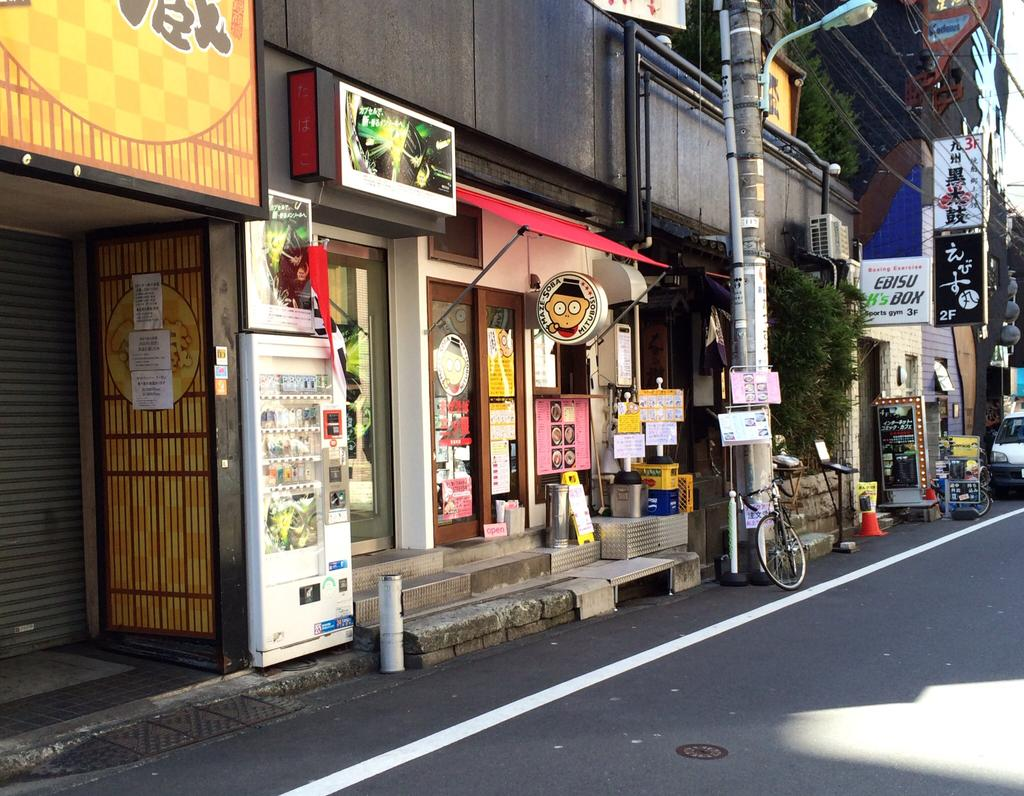What type of vehicle can be seen in the image? There is a car in the image. What other mode of transportation is visible in the image? There is a bicycle in the image. What objects are present in the image that might be used for construction or signage? There are boards and poles in the image. What source of illumination is visible in the image? There is a light in the image. What type of natural elements can be seen in the image? There are plants in the image. What type of decorative or informative items are visible in the image? There are posters in the image. What type of man-made structures can be seen in the image? There are buildings in the image. What type of setting is depicted in the image? The image depicts a road. Where is the toothbrush located in the image? There is no toothbrush present in the image. How many cherries are visible on the bicycle in the image? There are no cherries present in the image, and the bicycle is not mentioned as having any cherries. 